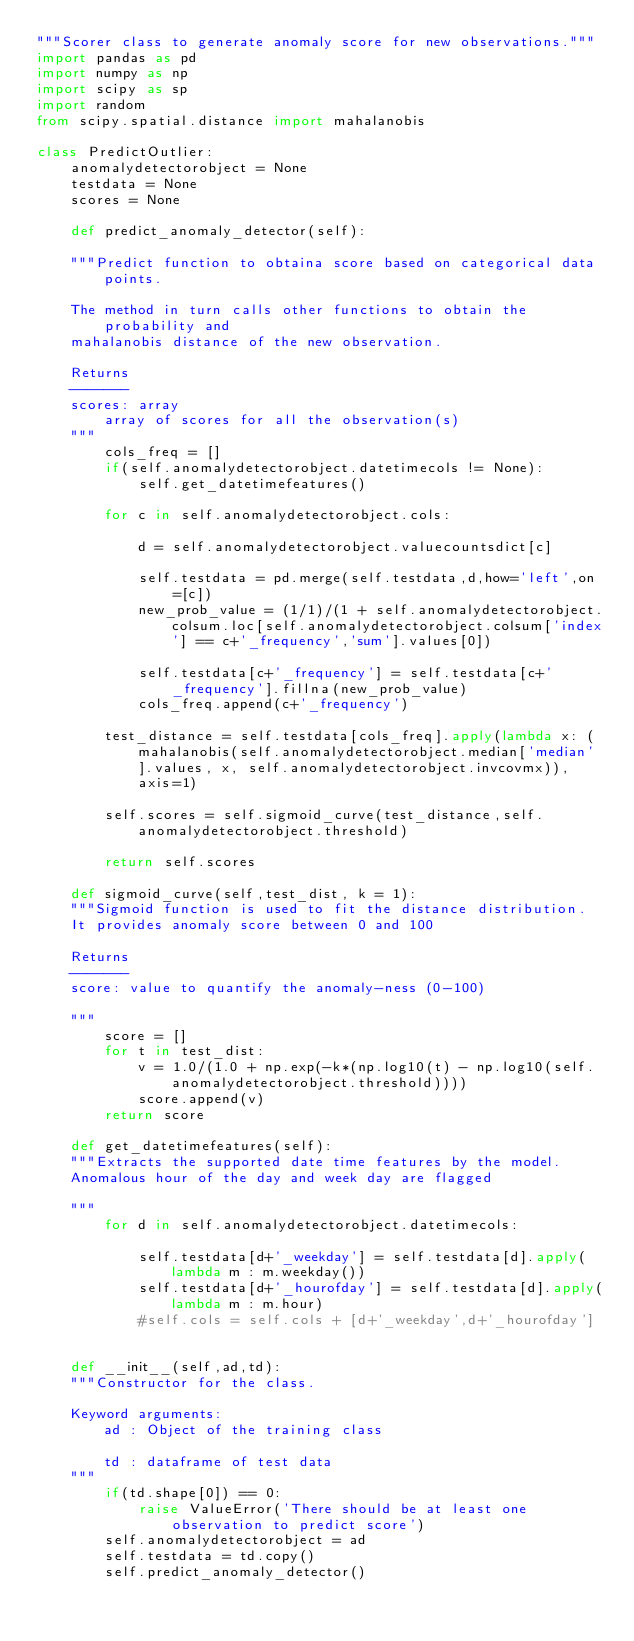Convert code to text. <code><loc_0><loc_0><loc_500><loc_500><_Python_>"""Scorer class to generate anomaly score for new observations."""
import pandas as pd
import numpy as np
import scipy as sp
import random
from scipy.spatial.distance import mahalanobis

class PredictOutlier:
    anomalydetectorobject = None
    testdata = None
    scores = None
    
    def predict_anomaly_detector(self):
        
    """Predict function to obtaina score based on categorical data points.
    
    The method in turn calls other functions to obtain the probability and
    mahalanobis distance of the new observation.
    
    Returns
    -------
    scores: array
        array of scores for all the observation(s)
    """
        cols_freq = []
        if(self.anomalydetectorobject.datetimecols != None):
            self.get_datetimefeatures()
            
        for c in self.anomalydetectorobject.cols:
            
            d = self.anomalydetectorobject.valuecountsdict[c]
            
            self.testdata = pd.merge(self.testdata,d,how='left',on=[c])
            new_prob_value = (1/1)/(1 + self.anomalydetectorobject.colsum.loc[self.anomalydetectorobject.colsum['index'] == c+'_frequency','sum'].values[0])
            
            self.testdata[c+'_frequency'] = self.testdata[c+'_frequency'].fillna(new_prob_value)
            cols_freq.append(c+'_frequency')

        test_distance = self.testdata[cols_freq].apply(lambda x: (mahalanobis(self.anomalydetectorobject.median['median'].values, x, self.anomalydetectorobject.invcovmx)), axis=1)

        self.scores = self.sigmoid_curve(test_distance,self.anomalydetectorobject.threshold)

        return self.scores
    
    def sigmoid_curve(self,test_dist, k = 1):
    """Sigmoid function is used to fit the distance distribution.
    It provides anomaly score between 0 and 100
    
    Returns
    -------
    score: value to quantify the anomaly-ness (0-100)
        
    """
        score = []
        for t in test_dist:
            v = 1.0/(1.0 + np.exp(-k*(np.log10(t) - np.log10(self.anomalydetectorobject.threshold))))
            score.append(v)
        return score
    
    def get_datetimefeatures(self):
    """Extracts the supported date time features by the model.
    Anomalous hour of the day and week day are flagged
        
    """
        for d in self.anomalydetectorobject.datetimecols:
            
            self.testdata[d+'_weekday'] = self.testdata[d].apply(lambda m : m.weekday())
            self.testdata[d+'_hourofday'] = self.testdata[d].apply(lambda m : m.hour)
            #self.cols = self.cols + [d+'_weekday',d+'_hourofday']
        
    
    def __init__(self,ad,td):
    """Constructor for the class.
    
    Keyword arguments:
        ad : Object of the training class
        
        td : dataframe of test data
    """
        if(td.shape[0]) == 0:
            raise ValueError('There should be at least one observation to predict score')
        self.anomalydetectorobject = ad
        self.testdata = td.copy()
        self.predict_anomaly_detector()
        
</code> 